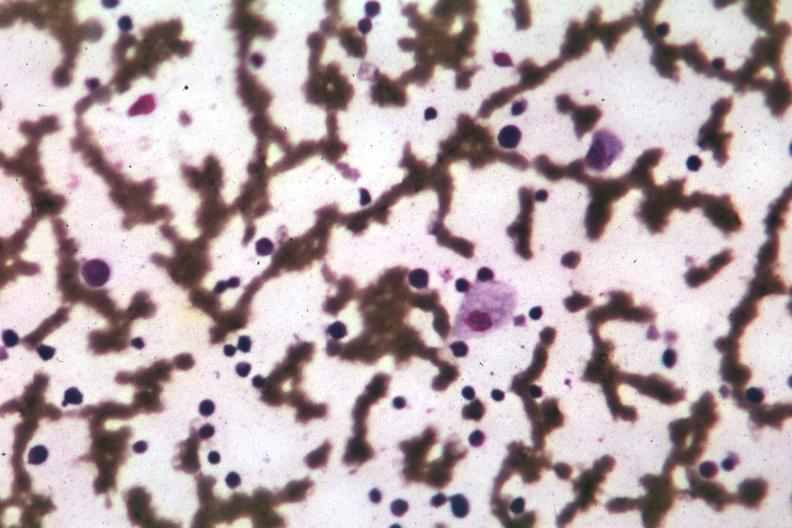s wrights single cell seen seen?
Answer the question using a single word or phrase. Yes 